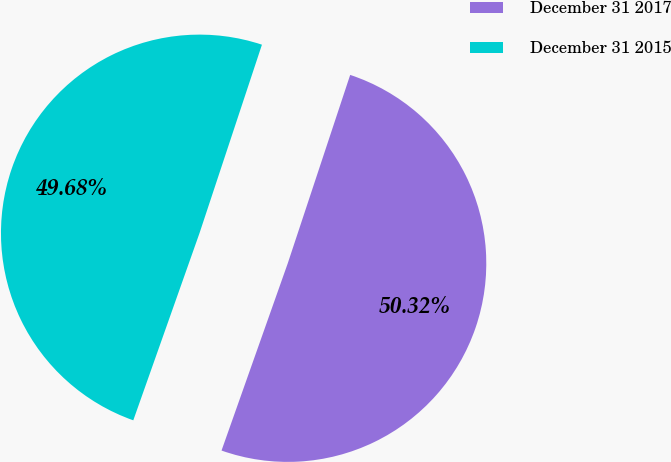<chart> <loc_0><loc_0><loc_500><loc_500><pie_chart><fcel>December 31 2017<fcel>December 31 2015<nl><fcel>50.32%<fcel>49.68%<nl></chart> 